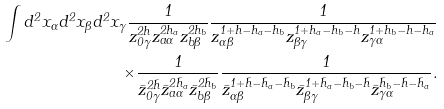Convert formula to latex. <formula><loc_0><loc_0><loc_500><loc_500>\int d ^ { 2 } x _ { \alpha } d ^ { 2 } x _ { \beta } d ^ { 2 } x _ { \gamma } \frac { 1 } { z ^ { 2 h } _ { 0 \gamma } z ^ { 2 h _ { a } } _ { a \alpha } z ^ { 2 h _ { b } } _ { b \beta } } \frac { 1 } { z _ { \alpha \beta } ^ { 1 + h - h _ { a } - h _ { b } } z _ { \beta \gamma } ^ { 1 + h _ { a } - h _ { b } - h } z _ { \gamma \alpha } ^ { 1 + h _ { b } - h - h _ { a } } } \\ \times \frac { 1 } { \bar { z } ^ { 2 \bar { h } } _ { 0 \gamma } \bar { z } ^ { 2 \bar { h } _ { a } } _ { a \alpha } \bar { z } ^ { 2 \bar { h } _ { b } } _ { b \beta } } \frac { 1 } { \bar { z } _ { \alpha \beta } ^ { 1 + \bar { h } - \bar { h } _ { a } - \bar { h } _ { b } } \bar { z } _ { \beta \gamma } ^ { 1 + \bar { h } _ { a } - \bar { h } _ { b } - \bar { h } } \bar { z } _ { \gamma \alpha } ^ { \bar { h } _ { b } - \bar { h } - \bar { h } _ { a } } } .</formula> 